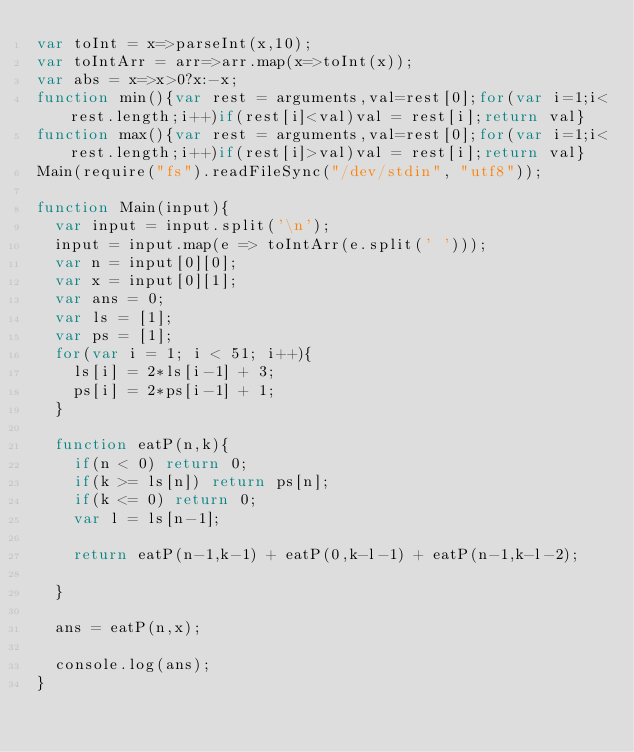<code> <loc_0><loc_0><loc_500><loc_500><_JavaScript_>var toInt = x=>parseInt(x,10);
var toIntArr = arr=>arr.map(x=>toInt(x));
var abs = x=>x>0?x:-x;
function min(){var rest = arguments,val=rest[0];for(var i=1;i<rest.length;i++)if(rest[i]<val)val = rest[i];return val}
function max(){var rest = arguments,val=rest[0];for(var i=1;i<rest.length;i++)if(rest[i]>val)val = rest[i];return val}
Main(require("fs").readFileSync("/dev/stdin", "utf8"));
 
function Main(input){
	var input = input.split('\n');
	input = input.map(e => toIntArr(e.split(' ')));
	var n = input[0][0];
	var x = input[0][1];
	var ans = 0;
	var ls = [1];
	var ps = [1];
	for(var i = 1; i < 51; i++){
		ls[i] = 2*ls[i-1] + 3;
		ps[i] = 2*ps[i-1] + 1;
	}

	function eatP(n,k){
		if(n < 0) return 0;
		if(k >= ls[n]) return ps[n];
		if(k <= 0) return 0;
		var l = ls[n-1];

		return eatP(n-1,k-1) + eatP(0,k-l-1) + eatP(n-1,k-l-2);

	}

	ans = eatP(n,x);
	
	console.log(ans);
}</code> 